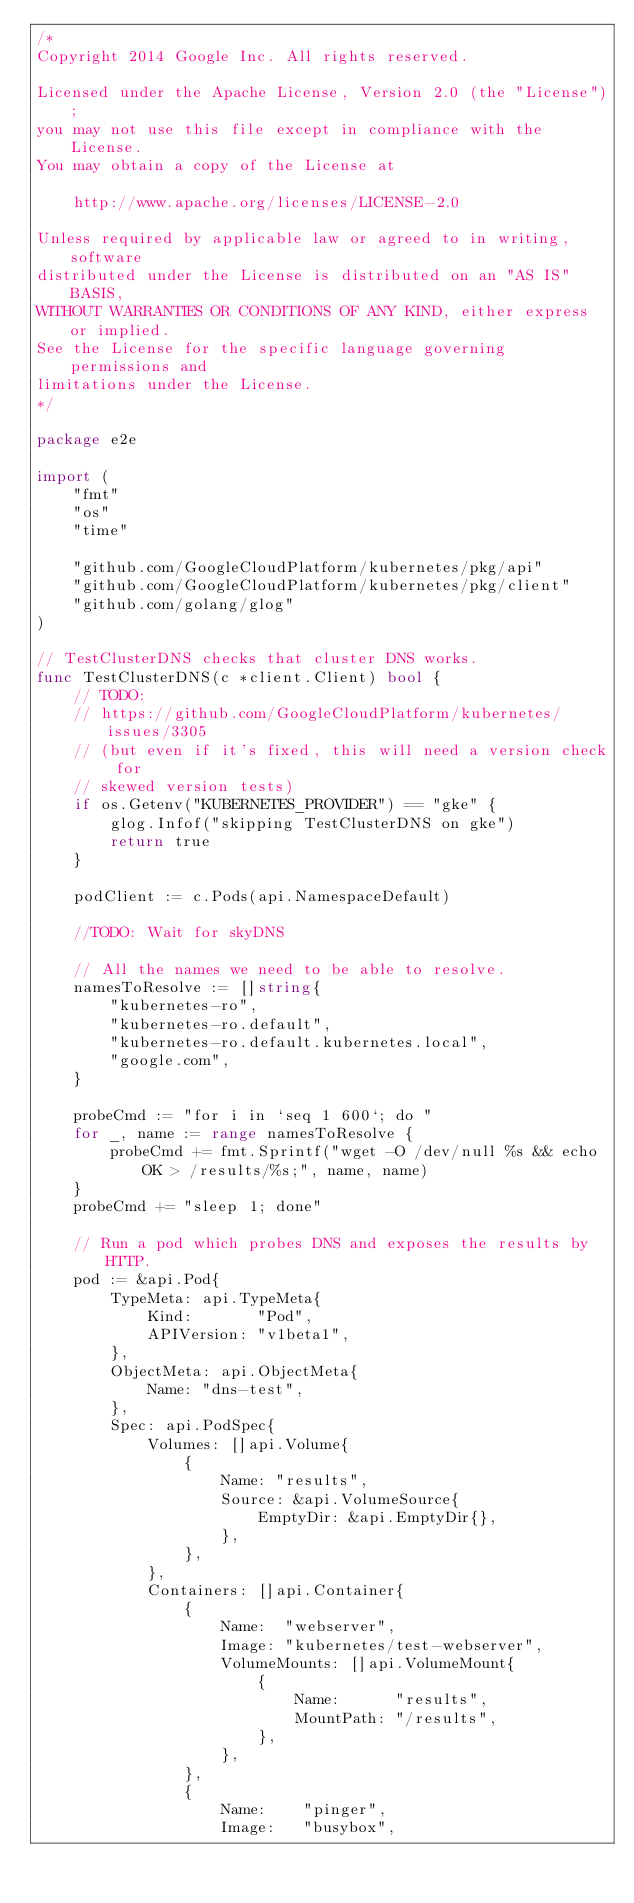<code> <loc_0><loc_0><loc_500><loc_500><_Go_>/*
Copyright 2014 Google Inc. All rights reserved.

Licensed under the Apache License, Version 2.0 (the "License");
you may not use this file except in compliance with the License.
You may obtain a copy of the License at

    http://www.apache.org/licenses/LICENSE-2.0

Unless required by applicable law or agreed to in writing, software
distributed under the License is distributed on an "AS IS" BASIS,
WITHOUT WARRANTIES OR CONDITIONS OF ANY KIND, either express or implied.
See the License for the specific language governing permissions and
limitations under the License.
*/

package e2e

import (
	"fmt"
	"os"
	"time"

	"github.com/GoogleCloudPlatform/kubernetes/pkg/api"
	"github.com/GoogleCloudPlatform/kubernetes/pkg/client"
	"github.com/golang/glog"
)

// TestClusterDNS checks that cluster DNS works.
func TestClusterDNS(c *client.Client) bool {
	// TODO:
	// https://github.com/GoogleCloudPlatform/kubernetes/issues/3305
	// (but even if it's fixed, this will need a version check for
	// skewed version tests)
	if os.Getenv("KUBERNETES_PROVIDER") == "gke" {
		glog.Infof("skipping TestClusterDNS on gke")
		return true
	}

	podClient := c.Pods(api.NamespaceDefault)

	//TODO: Wait for skyDNS

	// All the names we need to be able to resolve.
	namesToResolve := []string{
		"kubernetes-ro",
		"kubernetes-ro.default",
		"kubernetes-ro.default.kubernetes.local",
		"google.com",
	}

	probeCmd := "for i in `seq 1 600`; do "
	for _, name := range namesToResolve {
		probeCmd += fmt.Sprintf("wget -O /dev/null %s && echo OK > /results/%s;", name, name)
	}
	probeCmd += "sleep 1; done"

	// Run a pod which probes DNS and exposes the results by HTTP.
	pod := &api.Pod{
		TypeMeta: api.TypeMeta{
			Kind:       "Pod",
			APIVersion: "v1beta1",
		},
		ObjectMeta: api.ObjectMeta{
			Name: "dns-test",
		},
		Spec: api.PodSpec{
			Volumes: []api.Volume{
				{
					Name: "results",
					Source: &api.VolumeSource{
						EmptyDir: &api.EmptyDir{},
					},
				},
			},
			Containers: []api.Container{
				{
					Name:  "webserver",
					Image: "kubernetes/test-webserver",
					VolumeMounts: []api.VolumeMount{
						{
							Name:      "results",
							MountPath: "/results",
						},
					},
				},
				{
					Name:    "pinger",
					Image:   "busybox",</code> 